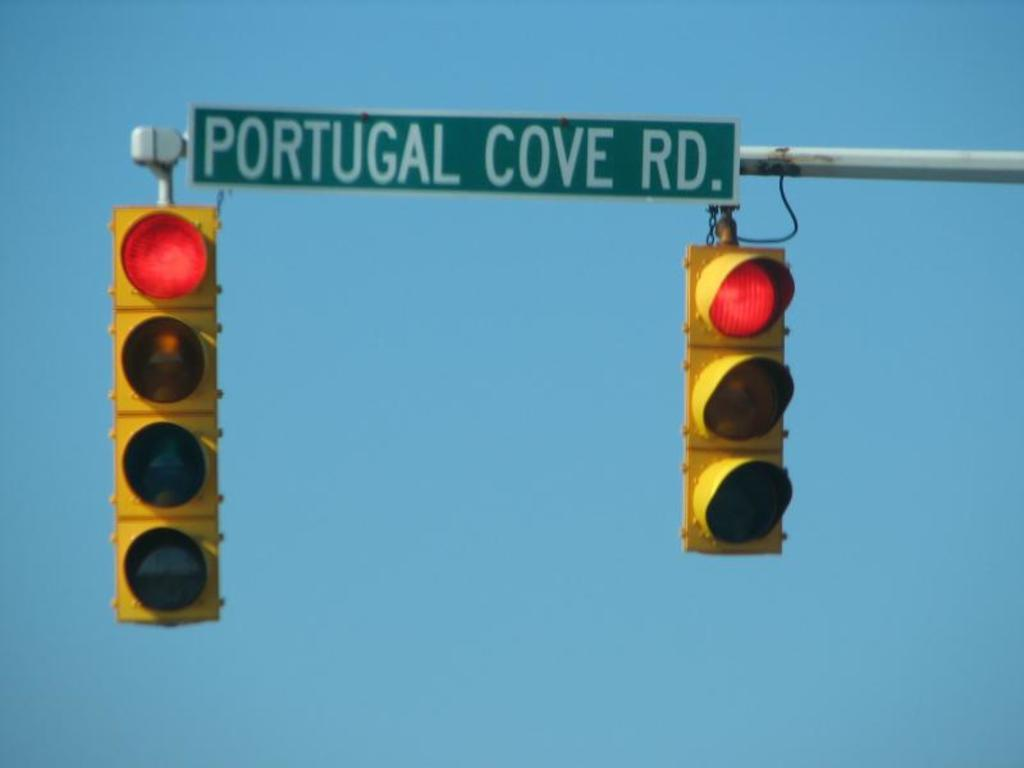Provide a one-sentence caption for the provided image. Portugal Cove Road's street sign is above two traffic lights that are on red. 